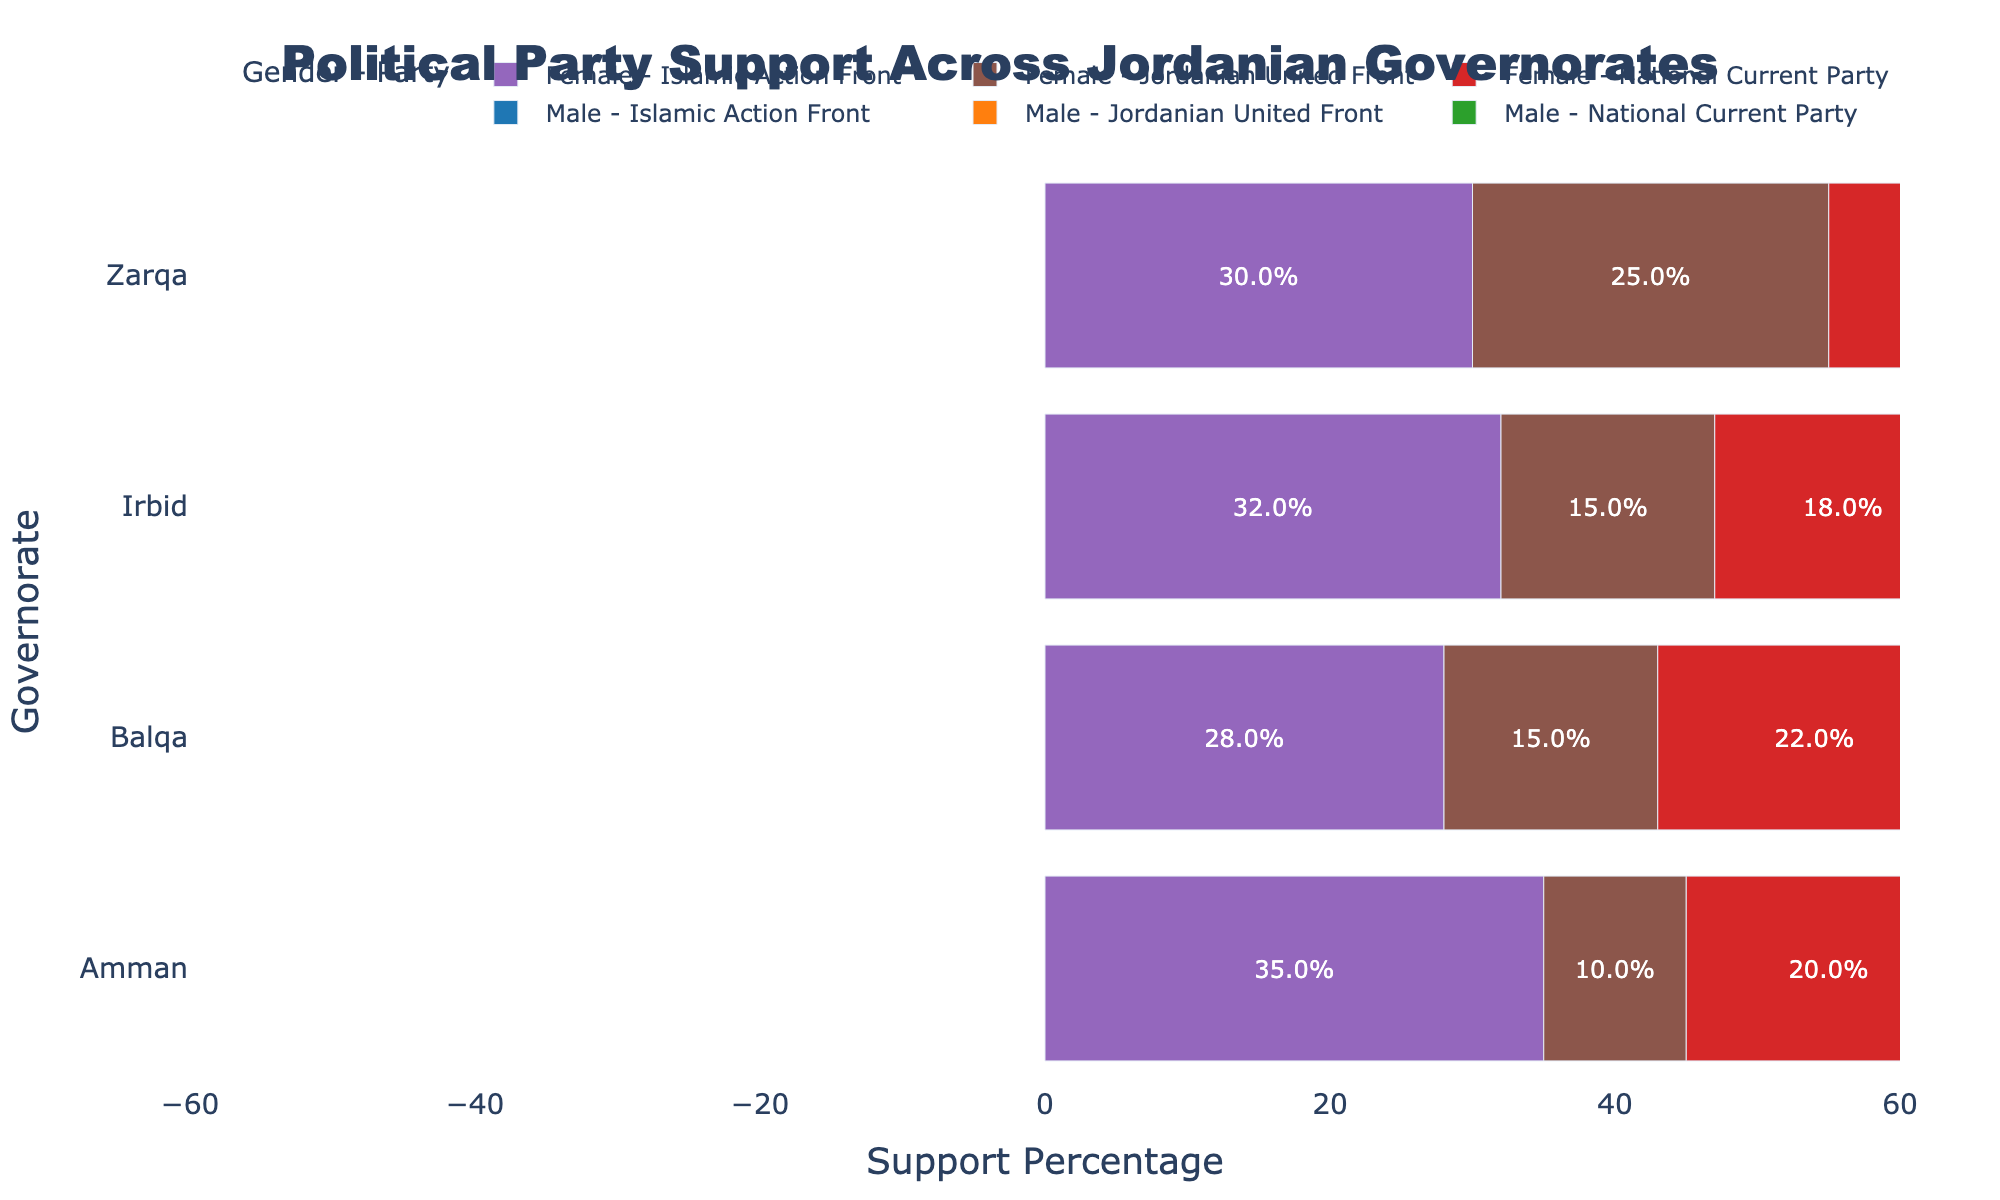Which governorate has the highest combined support for the Islamic Action Front among both genders? Combine the support percentages for Male and Female for the Islamic Action Front in each governorate:
   - Amman: 30% + 35% = 65%
   - Irbid: 28% + 32% = 60%
   - Zarqa: 32% + 30% = 62%
   - Balqa: 25% + 28% = 53%
So, Amman has the highest combined support at 65%.
Answer: Amman Which party has the least support in Irbid for each gender separately? In Irbid, compare the support percentages for each party and gender:
   - Male: Islamic Action Front: 28%, National Current Party: 22%, Jordanian United Front: 20%
   - Female: Islamic Action Front: 32%, National Current Party: 18%, Jordanian United Front: 15%
The Jordanian United Front has the least support for both Male (20%) and Female (15%).
Answer: Jordanian United Front What is the difference in support percentage between males and females for the National Current Party in Zarqa? Find the support percentages for the National Current Party in Zarqa:
   - Male: 18%
   - Female: 20%
Calculate the difference: 20% - 18% = 2%
Answer: 2% Compare the support percentages for the Jordanian United Front across all governorates for males. Which governorate shows the highest support? Compare the male support percentages for the Jordanian United Front:
   - Amman: 15%
   - Irbid: 20%
   - Zarqa: 20%
   - Balqa: 18%
Both Irbid and Zarqa show 20% support, which is the highest.
Answer: Irbid and Zarqa Which gender shows higher support for the Islamic Action Front in Balqa? Compare the support percentages for the Islamic Action Front in Balqa:
   - Male: 25%
   - Female: 28%
The Female support is higher at 28%.
Answer: Female What is the combined support percentage for the National Current Party in Amman? Combine the male and female support percentages for the National Current Party in Amman:
   - Male: 25%
   - Female: 20%
So, 25% + 20% = 45%
Answer: 45% Compare the total support for Islamic Action Front in Irbid and Zarqa. Which governorate has a higher total? Combine the support percentages for both genders in each governorate:
   - Irbid: 28% (Male) + 32% (Female) = 60%
   - Zarqa: 32% (Male) + 30% (Female) = 62%
Zarqa has the higher total support at 62%.
Answer: Zarqa 